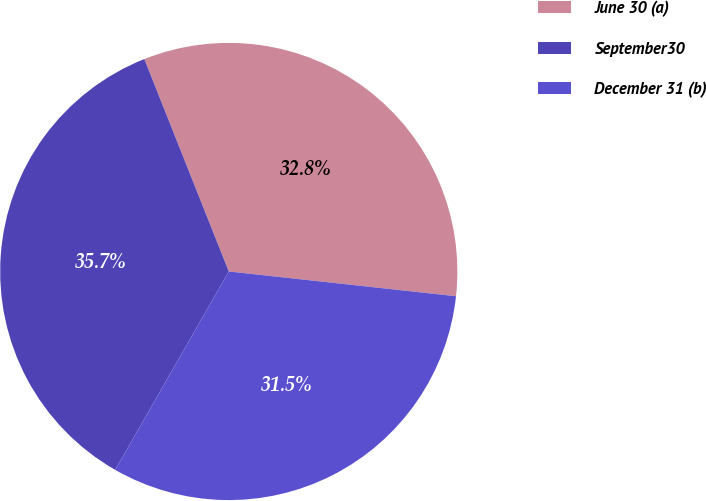Convert chart. <chart><loc_0><loc_0><loc_500><loc_500><pie_chart><fcel>June 30 (a)<fcel>September30<fcel>December 31 (b)<nl><fcel>32.75%<fcel>35.7%<fcel>31.55%<nl></chart> 